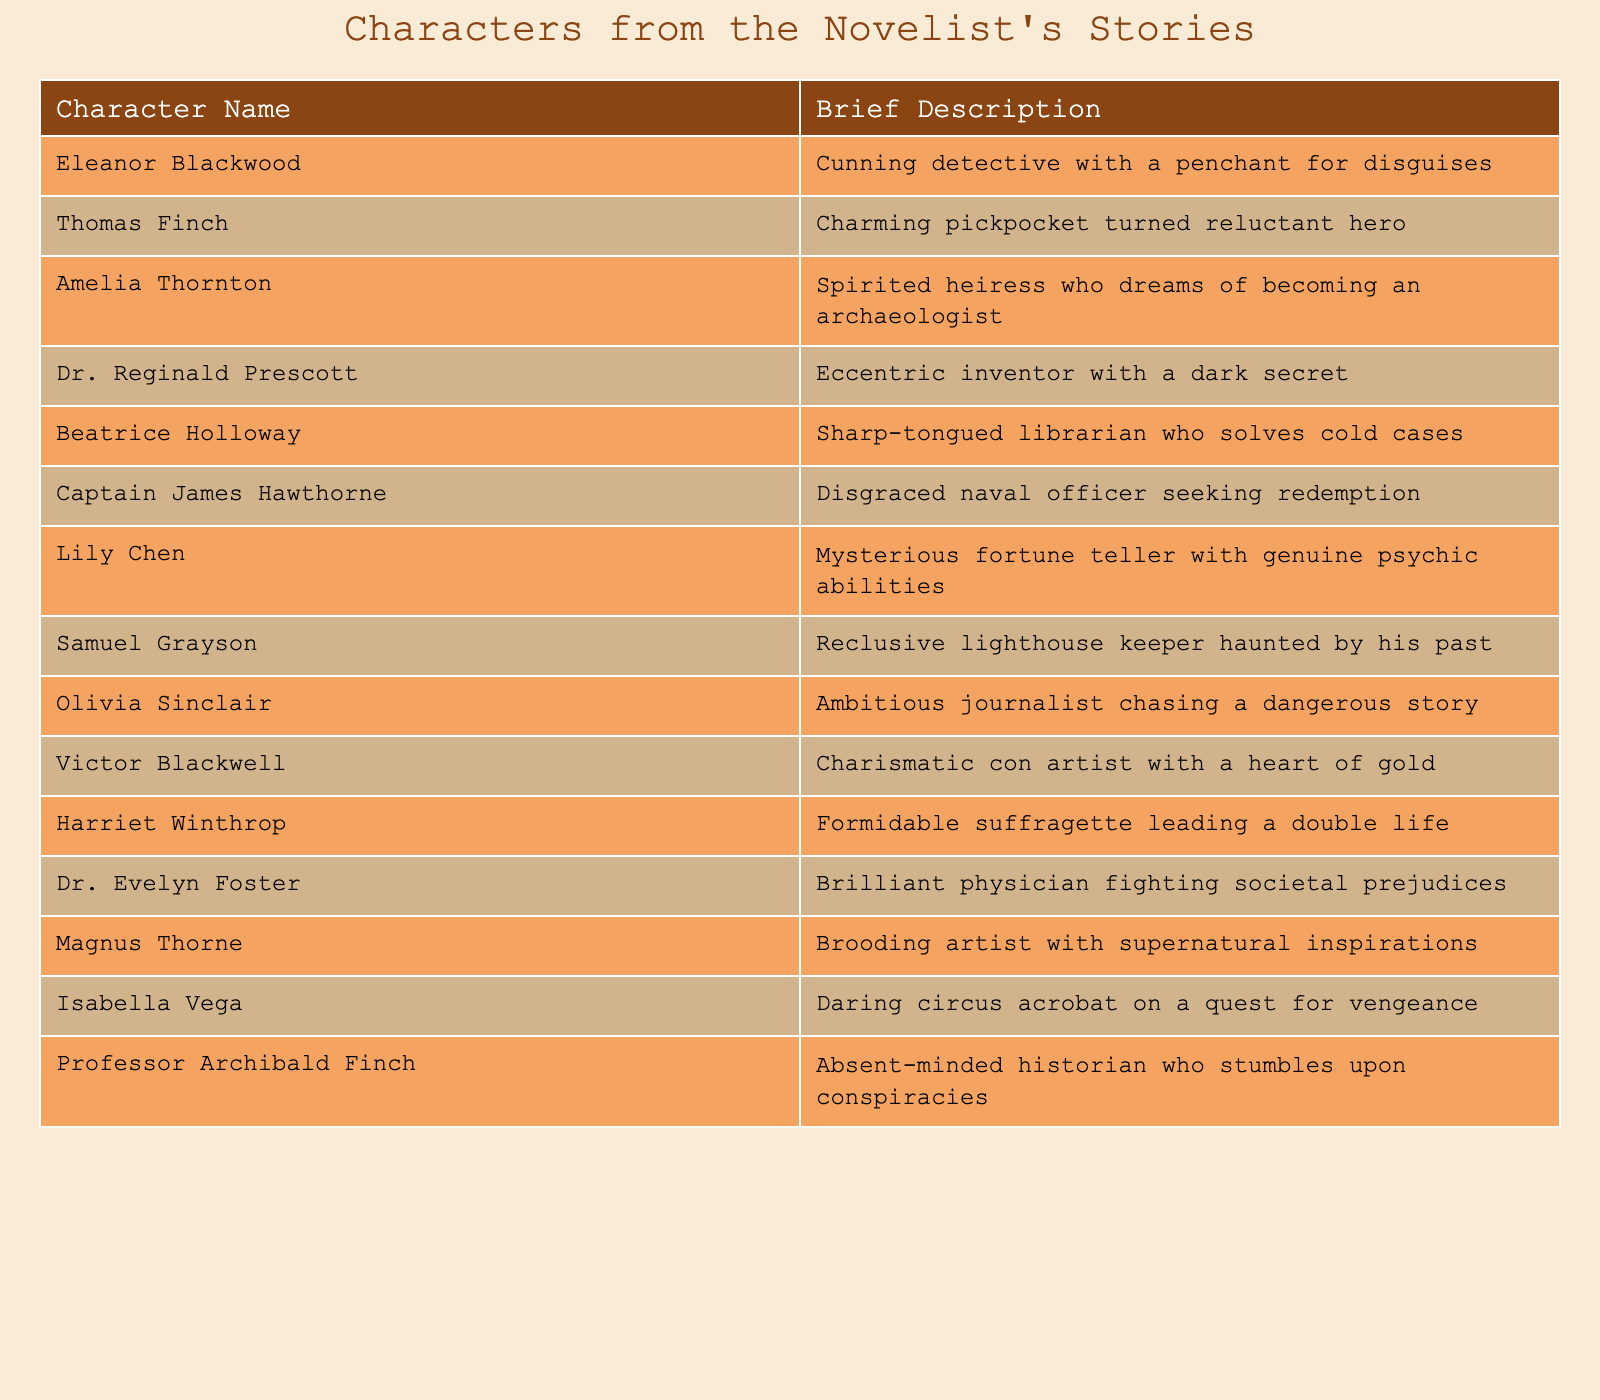What is the brief description of Eleanor Blackwood? According to the table, Eleanor Blackwood is described as a cunning detective with a penchant for disguises.
Answer: Cunning detective with a penchant for disguises Which character is a charming pickpocket turned reluctant hero? The table indicates that the character who is a charming pickpocket turned reluctant hero is Thomas Finch.
Answer: Thomas Finch How many characters are associated with a profession related to literature or history? The table shows two characters associated with literature or history: Beatrice Holloway, a librarian, and Professor Archibald Finch, an absent-minded historian. Thus, the total is 2.
Answer: 2 Is there a character that is described as both mysterious and psychic? The description provided for Lily Chen qualifies her as both mysterious and a fortune teller with genuine psychic abilities, confirming the presence of such a character in the table.
Answer: Yes Which character is the only physician mentioned in the table? The table shows that Dr. Evelyn Foster is the only character with the profession of a physician mentioned in the descriptions.
Answer: Dr. Evelyn Foster List the characters who have a quest for vengeance. From the table, Isabella Vega is specifically noted as a daring circus acrobat on a quest for vengeance. Therefore, she is the only character matching this description.
Answer: Isabella Vega How many characters have a background linked to either science or invention? The characters Dr. Reginald Prescott (an eccentric inventor) and Dr. Evelyn Foster (a physician) are linked to science or invention, giving a total of 2 characters.
Answer: 2 Are there more male characters or female characters in the table? By examining the list, it shows that the characters can be categorized into 5 male (Thomas Finch, Captain James Hawthorne, Victor Blackwell, Magnus Thorne, Professor Archibald Finch) and 7 female characters (Eleanor Blackwood, Amelia Thornton, Beatrice Holloway, Lily Chen, Olivia Sinclair, Harriet Winthrop, Dr. Evelyn Foster). Thus, there are more female characters.
Answer: Female characters What is the relationship between Captain James Hawthorne and redemption? The table states that Captain James Hawthorne is described as a disgraced naval officer seeking redemption, directly associating him with that theme.
Answer: Seeking redemption Which character, based on their description, could be involved in solving crimes? The character Beatrice Holloway, described as a sharp-tongued librarian who solves cold cases, indicates involvement in crime-solving.
Answer: Beatrice Holloway 